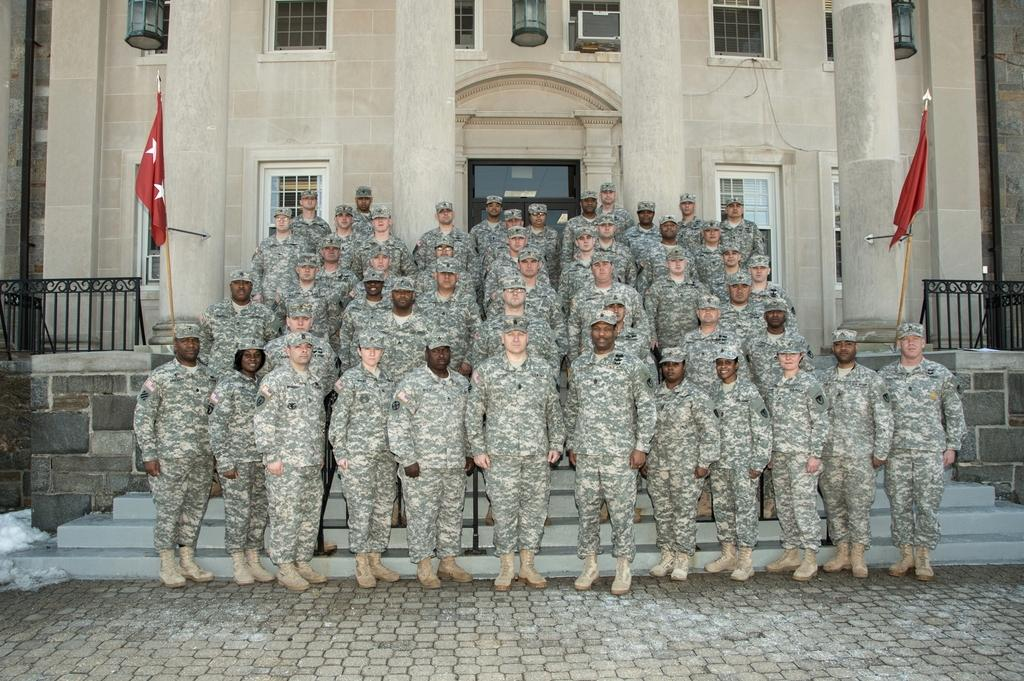How many people are in the image? There is a group of people in the image. What are the people doing in the image? The people are standing. What are the people wearing in the image? The people are wearing uniforms and hats. What can be seen in the background of the image? There is a fence, flags, and a building in the background of the image. What type of balloon is being held by the person in the image? There is no balloon present in the image. What kind of beast can be seen roaming in the background of the image? There are no beasts present in the image; only people, uniforms, hats, a fence, flags, and a building can be seen in the background. 